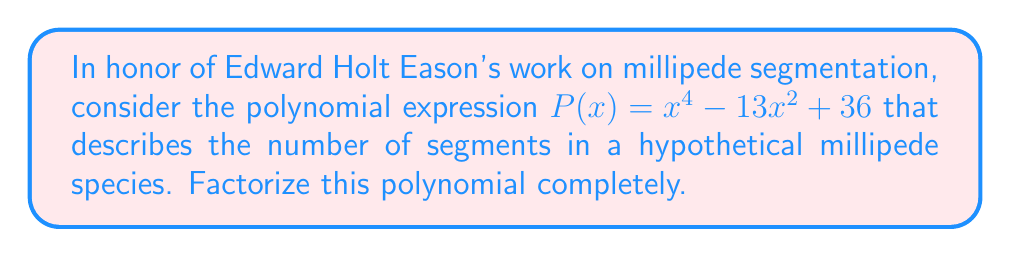Can you solve this math problem? Let's approach this step-by-step:

1) First, we recognize that this is a quadratic expression in $x^2$. Let's substitute $u = x^2$:

   $P(u) = u^2 - 13u + 36$

2) Now we can solve this as a quadratic equation. We'll use the quadratic formula:
   $u = \frac{-b \pm \sqrt{b^2 - 4ac}}{2a}$

   Here, $a=1$, $b=-13$, and $c=36$

3) Plugging into the formula:
   $u = \frac{13 \pm \sqrt{(-13)^2 - 4(1)(36)}}{2(1)}$
   $= \frac{13 \pm \sqrt{169 - 144}}{2}$
   $= \frac{13 \pm \sqrt{25}}{2}$
   $= \frac{13 \pm 5}{2}$

4) This gives us two solutions:
   $u_1 = \frac{13 + 5}{2} = 9$ and $u_2 = \frac{13 - 5}{2} = 4$

5) Remember that $u = x^2$, so:
   $x^2 = 9$ or $x^2 = 4$

6) Taking the square root of both sides (and considering both positive and negative roots):
   $x = \pm 3$ or $x = \pm 2$

7) Therefore, we can factorize $P(x)$ as:
   $P(x) = (x-3)(x+3)(x-2)(x+2)$

This factorization represents the possible segment numbers in our hypothetical millipede species, reflecting the symmetry often observed in millipede body plans.
Answer: $(x-3)(x+3)(x-2)(x+2)$ 